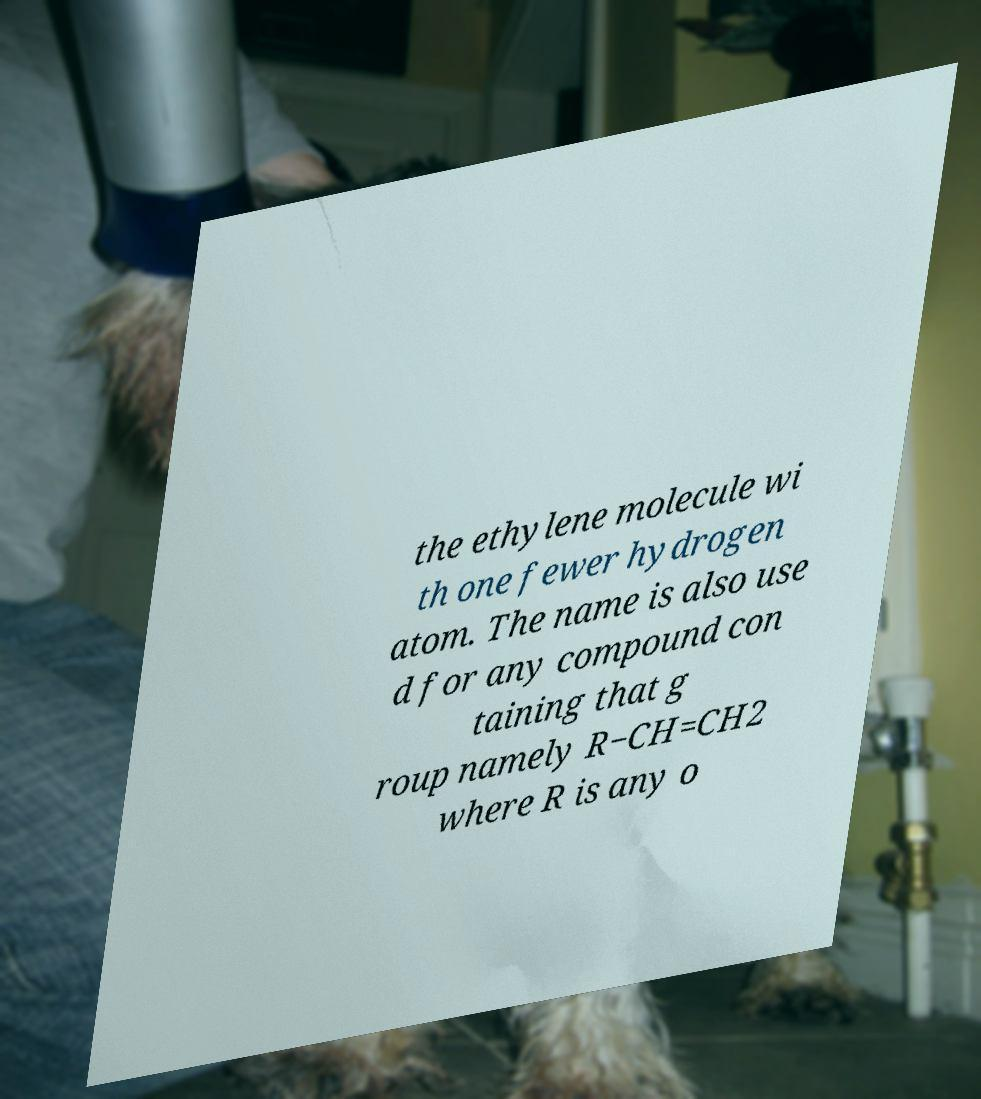I need the written content from this picture converted into text. Can you do that? the ethylene molecule wi th one fewer hydrogen atom. The name is also use d for any compound con taining that g roup namely R−CH=CH2 where R is any o 